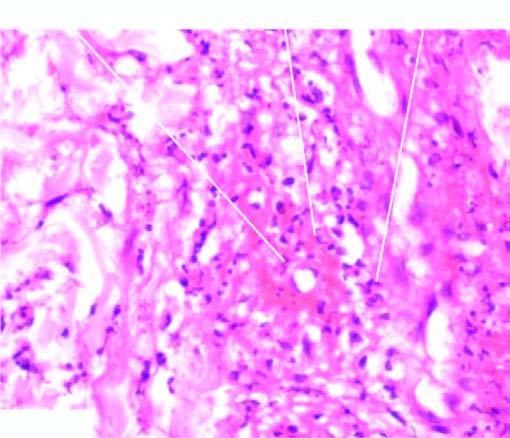what shows brightly pink amorphous material and nuclear fragments of necrosed neutrophils?
Answer the question using a single word or phrase. The vesselwall 